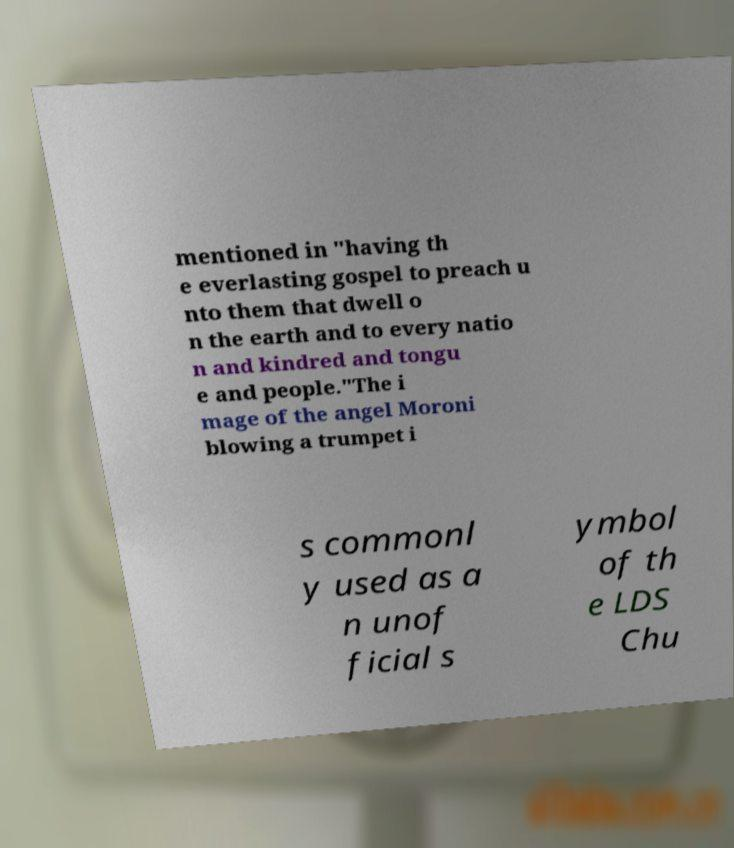Can you read and provide the text displayed in the image?This photo seems to have some interesting text. Can you extract and type it out for me? mentioned in "having th e everlasting gospel to preach u nto them that dwell o n the earth and to every natio n and kindred and tongu e and people."The i mage of the angel Moroni blowing a trumpet i s commonl y used as a n unof ficial s ymbol of th e LDS Chu 